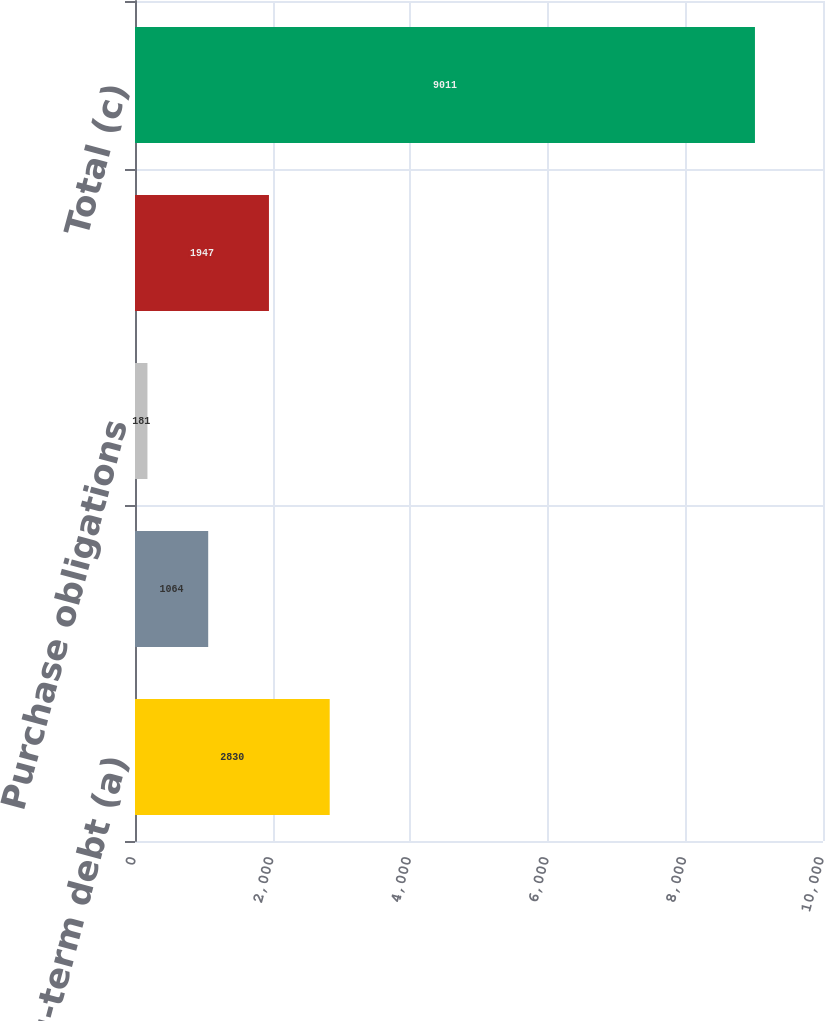Convert chart. <chart><loc_0><loc_0><loc_500><loc_500><bar_chart><fcel>Interest on long-term debt (a)<fcel>Operating leases<fcel>Purchase obligations<fcel>Deemed repatriation transition<fcel>Total (c)<nl><fcel>2830<fcel>1064<fcel>181<fcel>1947<fcel>9011<nl></chart> 